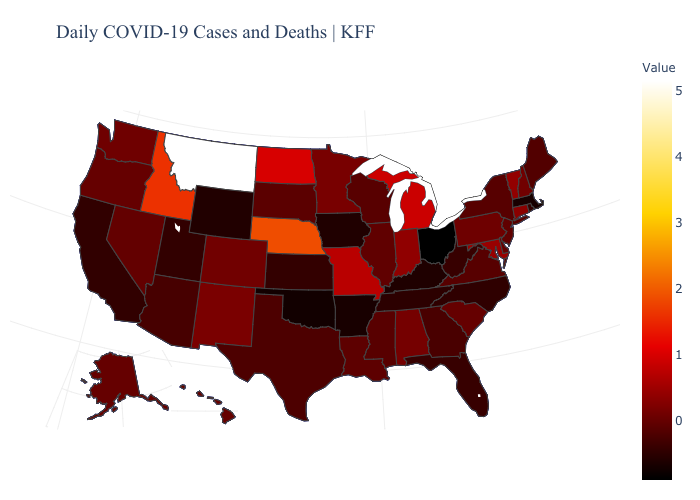Among the states that border Idaho , does Montana have the highest value?
Write a very short answer. Yes. Does Oklahoma have the lowest value in the South?
Short answer required. Yes. Does Connecticut have the lowest value in the USA?
Be succinct. No. Does the map have missing data?
Short answer required. No. Among the states that border Nevada , does Arizona have the highest value?
Give a very brief answer. No. Does Virginia have the highest value in the South?
Keep it brief. No. Does California have a lower value than North Dakota?
Give a very brief answer. Yes. 